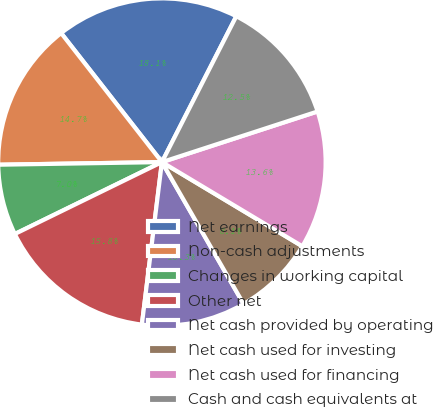Convert chart to OTSL. <chart><loc_0><loc_0><loc_500><loc_500><pie_chart><fcel>Net earnings<fcel>Non-cash adjustments<fcel>Changes in working capital<fcel>Other net<fcel>Net cash provided by operating<fcel>Net cash used for investing<fcel>Net cash used for financing<fcel>Cash and cash equivalents at<nl><fcel>18.06%<fcel>14.7%<fcel>6.98%<fcel>15.81%<fcel>10.27%<fcel>8.09%<fcel>13.6%<fcel>12.49%<nl></chart> 